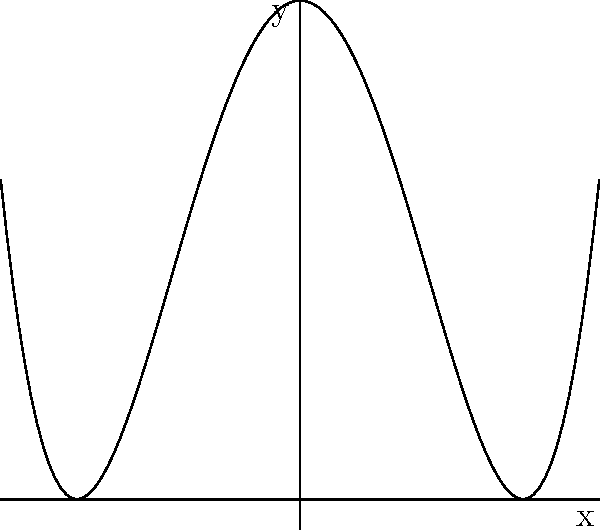Imagine you're on a hiking adventure and come across a mountain range that looks just like this graph! Can you identify the degree of the polynomial that creates this mountain-shaped curve? Let's explore this mountain-shaped graph step by step:

1. First, notice that the graph has two "peaks" or local maxima.

2. The curve goes up on both ends, forming a "U" shape overall.

3. For a polynomial to have this shape, it needs to be of even degree and the highest-degree term must have a positive coefficient.

4. The simplest polynomial that could create this shape would be a quadratic (degree 2), but that would only give us one peak.

5. The next even degree is 4, which can produce two peaks when combined with a quadratic term.

6. The general form of such a polynomial would be:
   $f(x) = ax^4 + bx^3 + cx^2 + dx + e$, where $a > 0$ and $c < 0$

7. Given the symmetry of the graph, we can assume there's no cubic term, so $b = 0$.

8. Therefore, the polynomial that creates this mountain range shape is of degree 4.
Answer: 4 